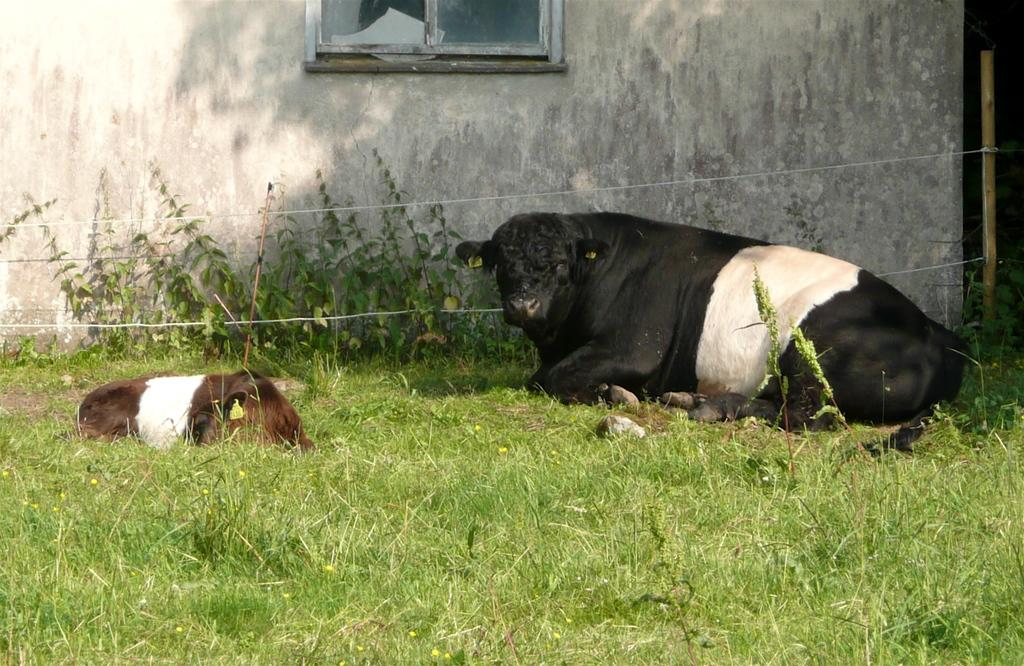How many animals are present in the image? There are two animals in the image. What is the setting where the animals are located? The animals are sitting on the grassland. What type of vegetation can be seen in the grassland? There are plants in the grassland. What can be seen in the background of the image? There is a wall with a window in the background. What object is tied with ropes on the right side of the image? There is a wooden stick tied with ropes on the right side of the image. Can you tell me how the animals are harmonizing with the cave in the image? There is no cave present in the image, so it is not possible to determine how the animals might be harmonizing with it. 